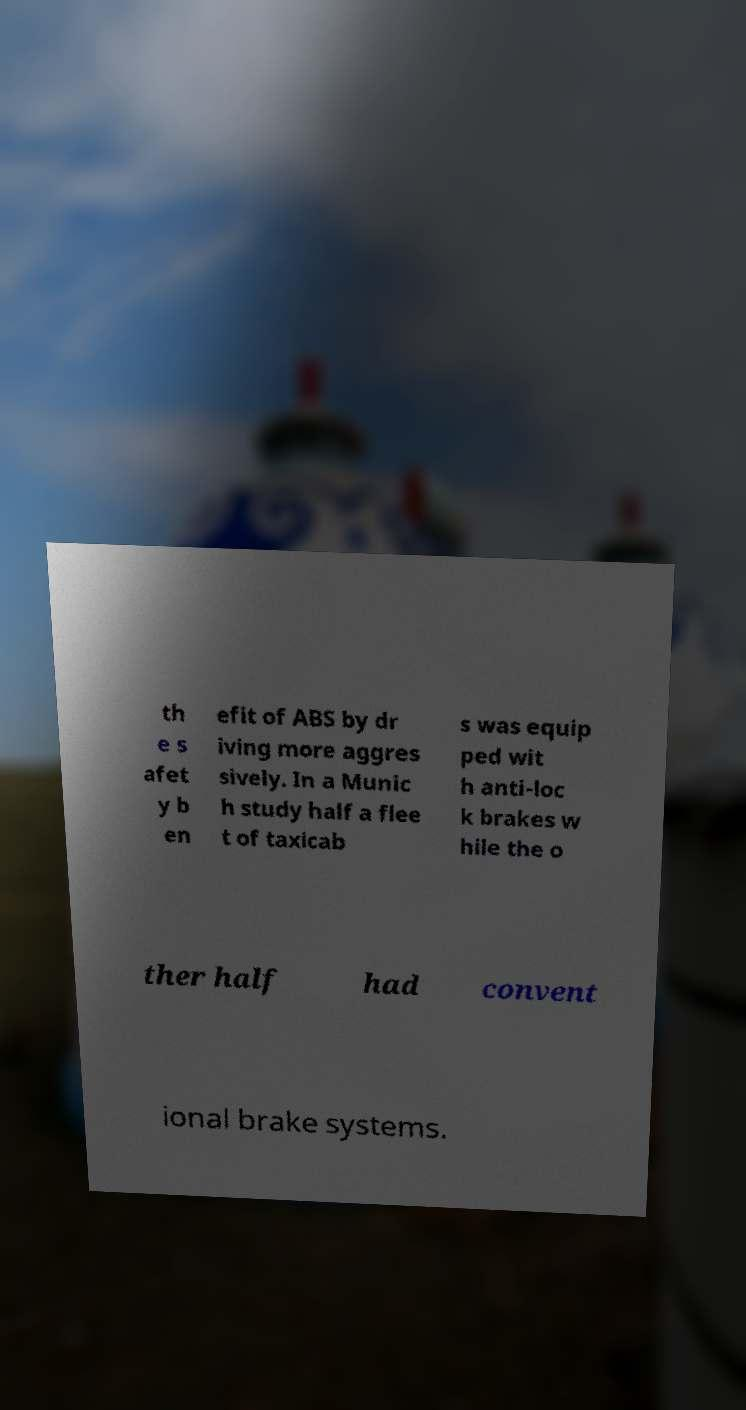Could you extract and type out the text from this image? th e s afet y b en efit of ABS by dr iving more aggres sively. In a Munic h study half a flee t of taxicab s was equip ped wit h anti-loc k brakes w hile the o ther half had convent ional brake systems. 